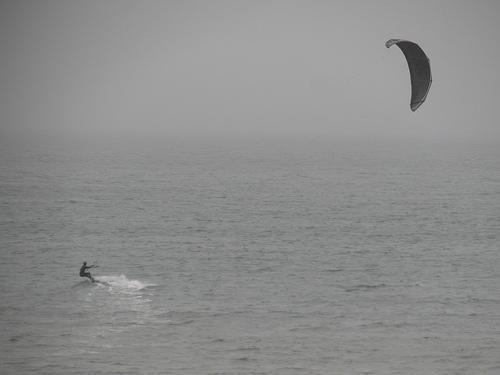How many people are shown?
Give a very brief answer. 1. 